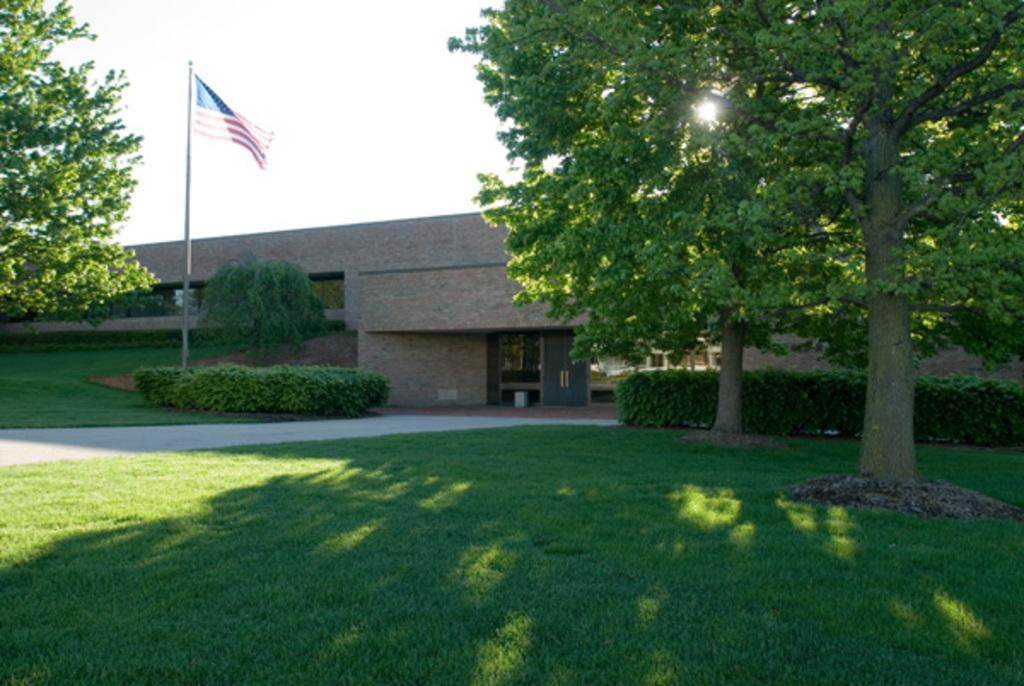What type of structure is present in the image? There is a building in the image. What is located in front of the building? There is a flag in front of the building. What type of vegetation surrounds the building? There are trees around the building. What type of ground cover is visible in the image? There is grass visible in the image. How many tickets are available for the harmony concert in the image? There is no mention of a harmony concert or tickets in the image. 